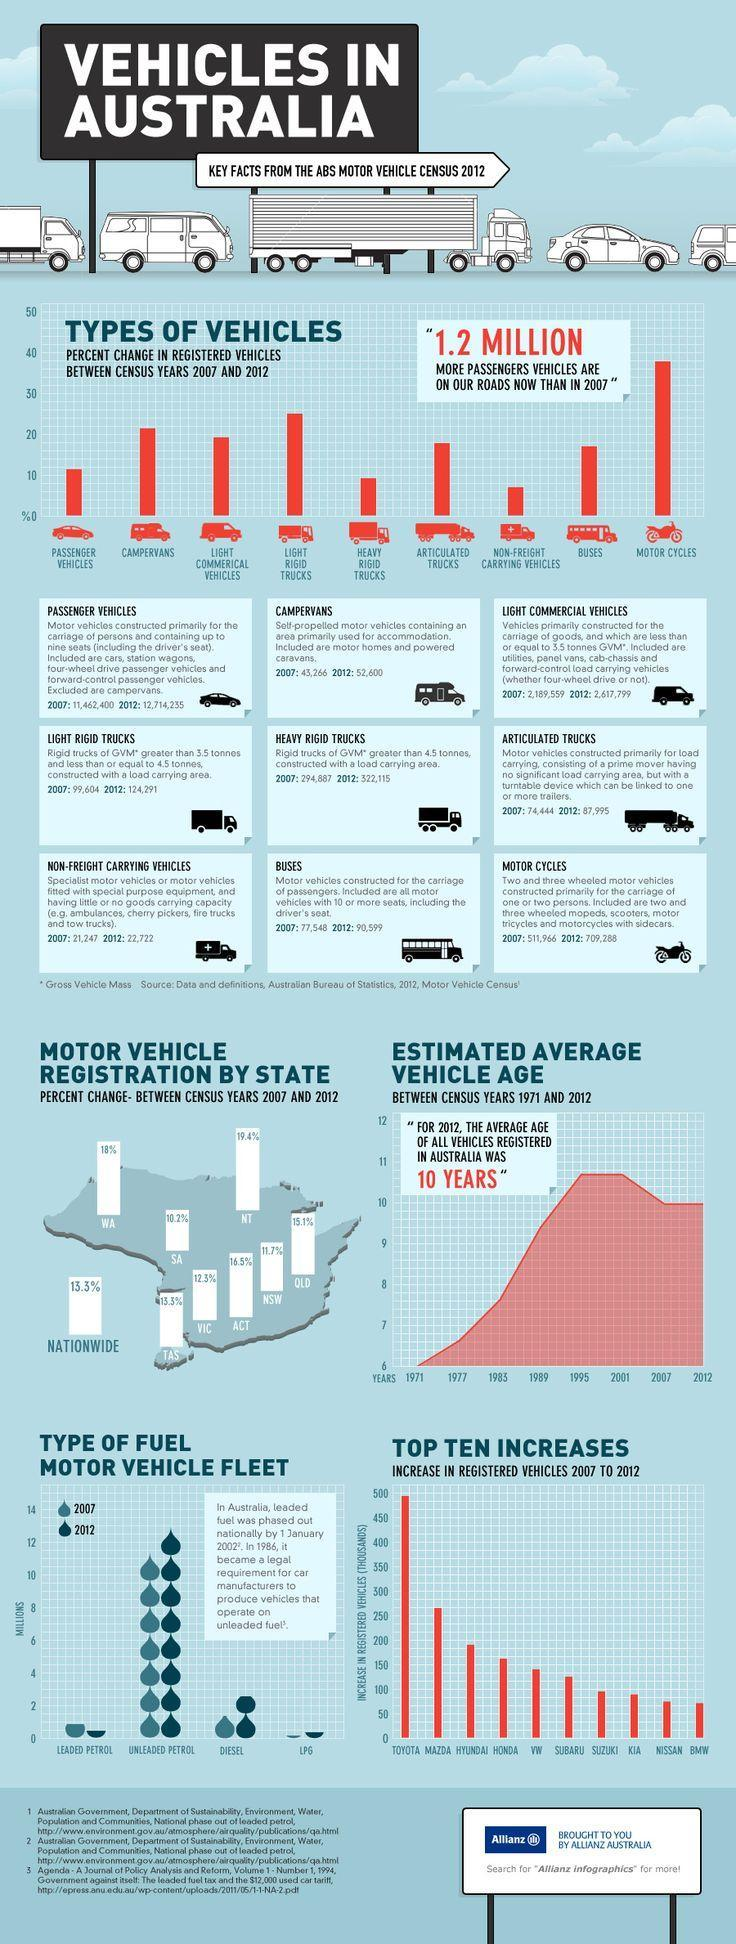How many vehicles have been considered for the study?
Answer the question with a short phrase. 9 Which vehicle had a percent change of 10%? PASSENGER VEHICLES Which vehicle has increased from 2007 to 2012? MOTOR CYCLES 